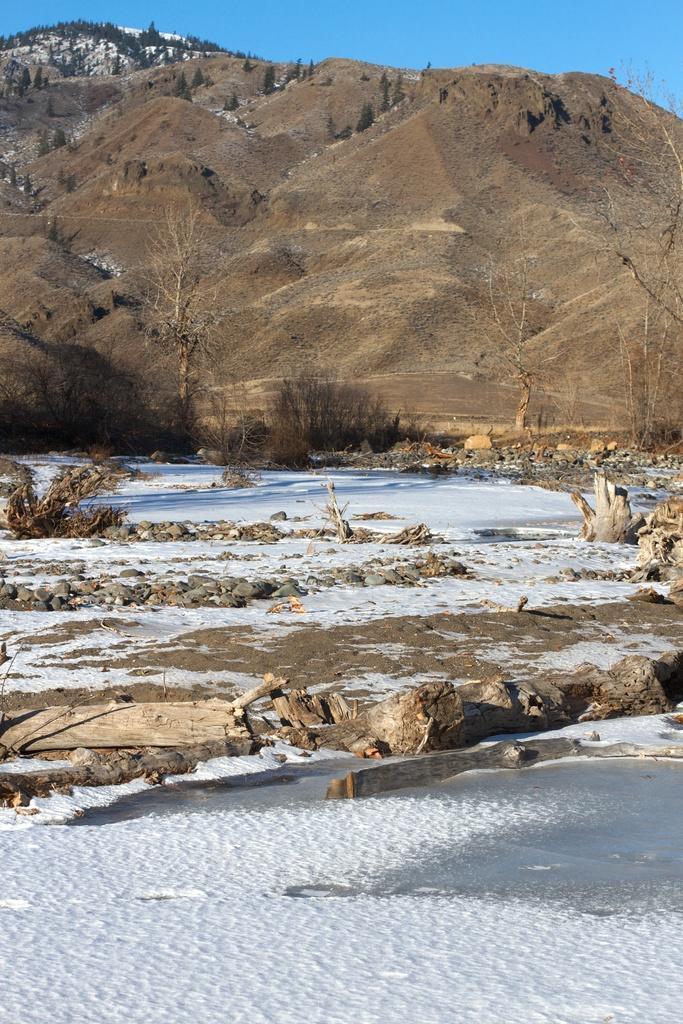Can you describe this image briefly? In this image we can see the rock, trees, stones and also the snow. We can also see the sky and also the barks. 